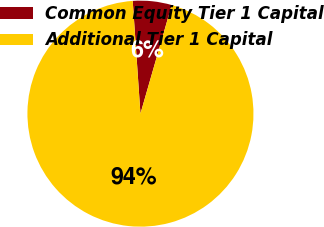Convert chart. <chart><loc_0><loc_0><loc_500><loc_500><pie_chart><fcel>Common Equity Tier 1 Capital<fcel>Additional Tier 1 Capital<nl><fcel>5.55%<fcel>94.45%<nl></chart> 